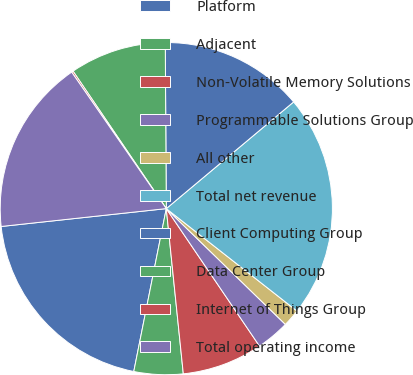Convert chart. <chart><loc_0><loc_0><loc_500><loc_500><pie_chart><fcel>Platform<fcel>Adjacent<fcel>Non-Volatile Memory Solutions<fcel>Programmable Solutions Group<fcel>All other<fcel>Total net revenue<fcel>Client Computing Group<fcel>Data Center Group<fcel>Internet of Things Group<fcel>Total operating income<nl><fcel>20.15%<fcel>4.77%<fcel>7.85%<fcel>3.24%<fcel>1.7%<fcel>21.68%<fcel>14.0%<fcel>9.39%<fcel>0.16%<fcel>17.07%<nl></chart> 